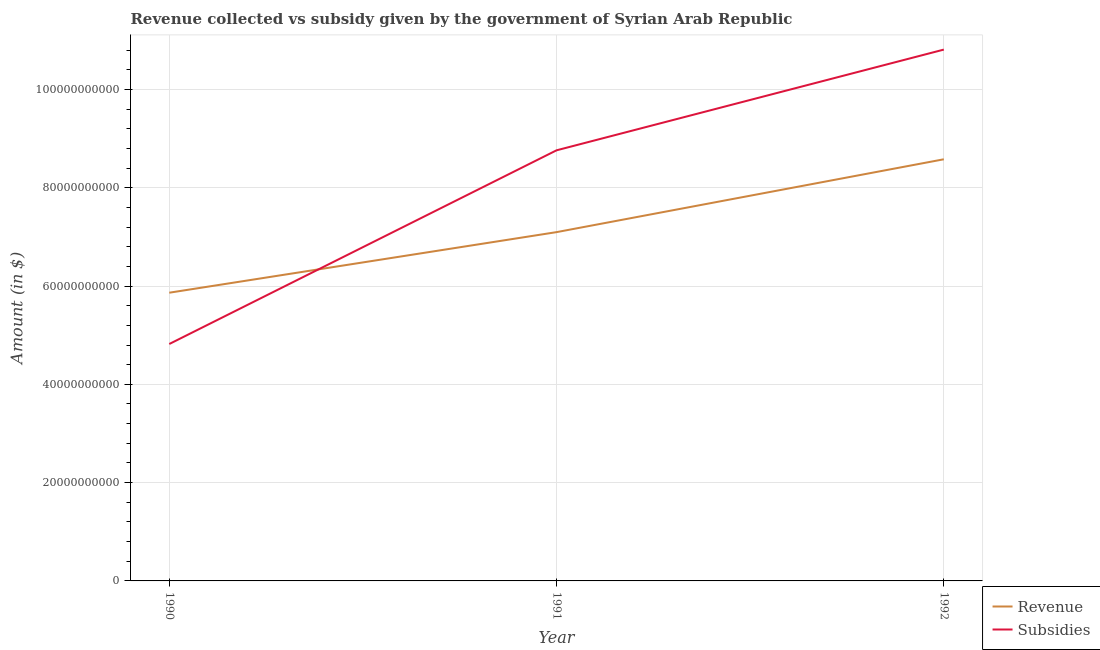Does the line corresponding to amount of subsidies given intersect with the line corresponding to amount of revenue collected?
Offer a very short reply. Yes. What is the amount of revenue collected in 1992?
Provide a short and direct response. 8.58e+1. Across all years, what is the maximum amount of revenue collected?
Ensure brevity in your answer.  8.58e+1. Across all years, what is the minimum amount of revenue collected?
Provide a short and direct response. 5.86e+1. In which year was the amount of subsidies given maximum?
Provide a short and direct response. 1992. What is the total amount of subsidies given in the graph?
Ensure brevity in your answer.  2.44e+11. What is the difference between the amount of revenue collected in 1990 and that in 1992?
Your response must be concise. -2.71e+1. What is the difference between the amount of subsidies given in 1990 and the amount of revenue collected in 1992?
Give a very brief answer. -3.76e+1. What is the average amount of subsidies given per year?
Keep it short and to the point. 8.13e+1. In the year 1992, what is the difference between the amount of subsidies given and amount of revenue collected?
Provide a short and direct response. 2.23e+1. What is the ratio of the amount of subsidies given in 1991 to that in 1992?
Offer a very short reply. 0.81. What is the difference between the highest and the second highest amount of revenue collected?
Keep it short and to the point. 1.48e+1. What is the difference between the highest and the lowest amount of subsidies given?
Provide a short and direct response. 5.99e+1. Is the sum of the amount of revenue collected in 1990 and 1992 greater than the maximum amount of subsidies given across all years?
Your answer should be compact. Yes. Is the amount of subsidies given strictly less than the amount of revenue collected over the years?
Make the answer very short. No. How many lines are there?
Your response must be concise. 2. How many years are there in the graph?
Provide a short and direct response. 3. What is the difference between two consecutive major ticks on the Y-axis?
Your answer should be very brief. 2.00e+1. Are the values on the major ticks of Y-axis written in scientific E-notation?
Provide a short and direct response. No. Does the graph contain any zero values?
Offer a very short reply. No. Does the graph contain grids?
Your answer should be very brief. Yes. How many legend labels are there?
Your answer should be compact. 2. What is the title of the graph?
Offer a very short reply. Revenue collected vs subsidy given by the government of Syrian Arab Republic. Does "Female" appear as one of the legend labels in the graph?
Provide a short and direct response. No. What is the label or title of the Y-axis?
Offer a terse response. Amount (in $). What is the Amount (in $) in Revenue in 1990?
Ensure brevity in your answer.  5.86e+1. What is the Amount (in $) in Subsidies in 1990?
Provide a succinct answer. 4.82e+1. What is the Amount (in $) of Revenue in 1991?
Offer a very short reply. 7.10e+1. What is the Amount (in $) of Subsidies in 1991?
Offer a terse response. 8.76e+1. What is the Amount (in $) in Revenue in 1992?
Your response must be concise. 8.58e+1. What is the Amount (in $) of Subsidies in 1992?
Your answer should be very brief. 1.08e+11. Across all years, what is the maximum Amount (in $) of Revenue?
Your answer should be compact. 8.58e+1. Across all years, what is the maximum Amount (in $) of Subsidies?
Keep it short and to the point. 1.08e+11. Across all years, what is the minimum Amount (in $) of Revenue?
Your answer should be compact. 5.86e+1. Across all years, what is the minimum Amount (in $) of Subsidies?
Provide a succinct answer. 4.82e+1. What is the total Amount (in $) in Revenue in the graph?
Provide a succinct answer. 2.15e+11. What is the total Amount (in $) of Subsidies in the graph?
Keep it short and to the point. 2.44e+11. What is the difference between the Amount (in $) of Revenue in 1990 and that in 1991?
Keep it short and to the point. -1.23e+1. What is the difference between the Amount (in $) in Subsidies in 1990 and that in 1991?
Ensure brevity in your answer.  -3.94e+1. What is the difference between the Amount (in $) in Revenue in 1990 and that in 1992?
Offer a very short reply. -2.71e+1. What is the difference between the Amount (in $) of Subsidies in 1990 and that in 1992?
Ensure brevity in your answer.  -5.99e+1. What is the difference between the Amount (in $) of Revenue in 1991 and that in 1992?
Offer a very short reply. -1.48e+1. What is the difference between the Amount (in $) of Subsidies in 1991 and that in 1992?
Your response must be concise. -2.05e+1. What is the difference between the Amount (in $) of Revenue in 1990 and the Amount (in $) of Subsidies in 1991?
Offer a very short reply. -2.90e+1. What is the difference between the Amount (in $) of Revenue in 1990 and the Amount (in $) of Subsidies in 1992?
Keep it short and to the point. -4.95e+1. What is the difference between the Amount (in $) in Revenue in 1991 and the Amount (in $) in Subsidies in 1992?
Provide a succinct answer. -3.71e+1. What is the average Amount (in $) in Revenue per year?
Give a very brief answer. 7.18e+1. What is the average Amount (in $) in Subsidies per year?
Offer a terse response. 8.13e+1. In the year 1990, what is the difference between the Amount (in $) of Revenue and Amount (in $) of Subsidies?
Your answer should be very brief. 1.04e+1. In the year 1991, what is the difference between the Amount (in $) in Revenue and Amount (in $) in Subsidies?
Your answer should be very brief. -1.66e+1. In the year 1992, what is the difference between the Amount (in $) in Revenue and Amount (in $) in Subsidies?
Ensure brevity in your answer.  -2.23e+1. What is the ratio of the Amount (in $) in Revenue in 1990 to that in 1991?
Your response must be concise. 0.83. What is the ratio of the Amount (in $) in Subsidies in 1990 to that in 1991?
Your answer should be compact. 0.55. What is the ratio of the Amount (in $) in Revenue in 1990 to that in 1992?
Your answer should be very brief. 0.68. What is the ratio of the Amount (in $) in Subsidies in 1990 to that in 1992?
Provide a short and direct response. 0.45. What is the ratio of the Amount (in $) in Revenue in 1991 to that in 1992?
Give a very brief answer. 0.83. What is the ratio of the Amount (in $) of Subsidies in 1991 to that in 1992?
Your answer should be compact. 0.81. What is the difference between the highest and the second highest Amount (in $) in Revenue?
Give a very brief answer. 1.48e+1. What is the difference between the highest and the second highest Amount (in $) of Subsidies?
Your answer should be compact. 2.05e+1. What is the difference between the highest and the lowest Amount (in $) of Revenue?
Provide a succinct answer. 2.71e+1. What is the difference between the highest and the lowest Amount (in $) of Subsidies?
Offer a terse response. 5.99e+1. 